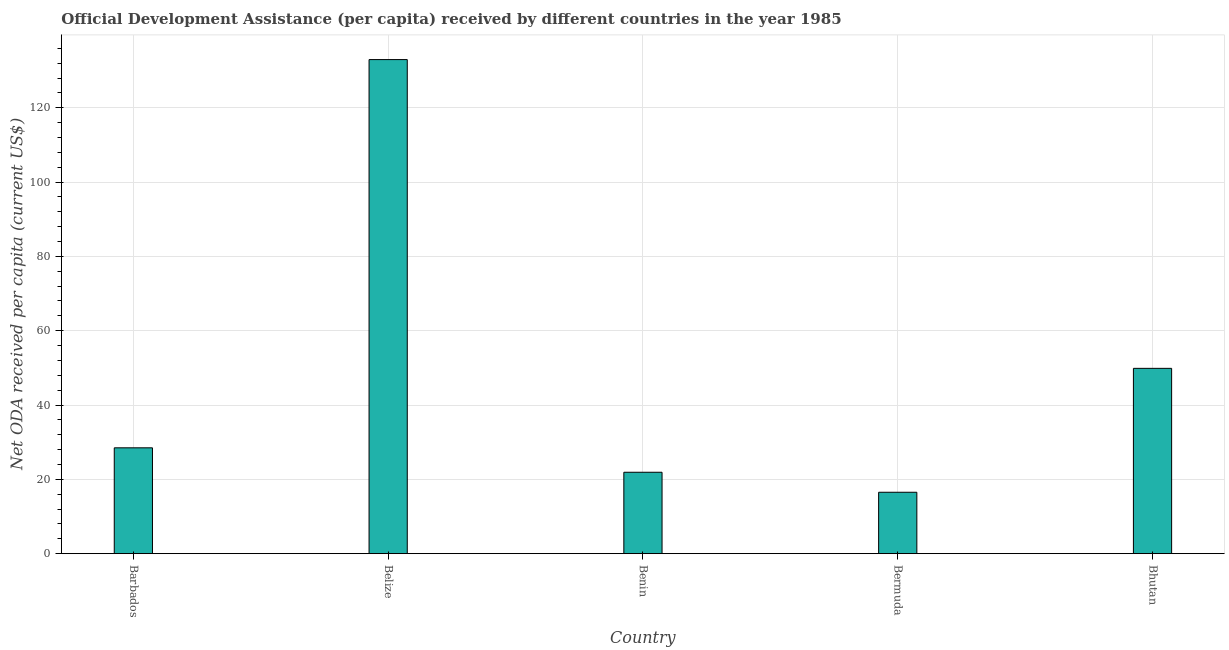What is the title of the graph?
Your response must be concise. Official Development Assistance (per capita) received by different countries in the year 1985. What is the label or title of the Y-axis?
Provide a succinct answer. Net ODA received per capita (current US$). What is the net oda received per capita in Benin?
Ensure brevity in your answer.  21.9. Across all countries, what is the maximum net oda received per capita?
Your response must be concise. 132.98. Across all countries, what is the minimum net oda received per capita?
Offer a terse response. 16.52. In which country was the net oda received per capita maximum?
Offer a terse response. Belize. In which country was the net oda received per capita minimum?
Keep it short and to the point. Bermuda. What is the sum of the net oda received per capita?
Provide a short and direct response. 249.76. What is the difference between the net oda received per capita in Barbados and Belize?
Your answer should be compact. -104.49. What is the average net oda received per capita per country?
Your answer should be very brief. 49.95. What is the median net oda received per capita?
Your response must be concise. 28.48. What is the ratio of the net oda received per capita in Belize to that in Bermuda?
Provide a short and direct response. 8.05. Is the net oda received per capita in Benin less than that in Bhutan?
Your answer should be compact. Yes. What is the difference between the highest and the second highest net oda received per capita?
Your answer should be compact. 83.11. What is the difference between the highest and the lowest net oda received per capita?
Make the answer very short. 116.46. In how many countries, is the net oda received per capita greater than the average net oda received per capita taken over all countries?
Offer a very short reply. 1. Are all the bars in the graph horizontal?
Your response must be concise. No. Are the values on the major ticks of Y-axis written in scientific E-notation?
Your answer should be compact. No. What is the Net ODA received per capita (current US$) in Barbados?
Make the answer very short. 28.48. What is the Net ODA received per capita (current US$) in Belize?
Give a very brief answer. 132.98. What is the Net ODA received per capita (current US$) of Benin?
Your answer should be compact. 21.9. What is the Net ODA received per capita (current US$) of Bermuda?
Your response must be concise. 16.52. What is the Net ODA received per capita (current US$) in Bhutan?
Offer a terse response. 49.87. What is the difference between the Net ODA received per capita (current US$) in Barbados and Belize?
Your response must be concise. -104.49. What is the difference between the Net ODA received per capita (current US$) in Barbados and Benin?
Keep it short and to the point. 6.58. What is the difference between the Net ODA received per capita (current US$) in Barbados and Bermuda?
Your response must be concise. 11.96. What is the difference between the Net ODA received per capita (current US$) in Barbados and Bhutan?
Your answer should be compact. -21.39. What is the difference between the Net ODA received per capita (current US$) in Belize and Benin?
Give a very brief answer. 111.07. What is the difference between the Net ODA received per capita (current US$) in Belize and Bermuda?
Offer a terse response. 116.46. What is the difference between the Net ODA received per capita (current US$) in Belize and Bhutan?
Your answer should be very brief. 83.11. What is the difference between the Net ODA received per capita (current US$) in Benin and Bermuda?
Make the answer very short. 5.38. What is the difference between the Net ODA received per capita (current US$) in Benin and Bhutan?
Ensure brevity in your answer.  -27.97. What is the difference between the Net ODA received per capita (current US$) in Bermuda and Bhutan?
Offer a terse response. -33.35. What is the ratio of the Net ODA received per capita (current US$) in Barbados to that in Belize?
Your response must be concise. 0.21. What is the ratio of the Net ODA received per capita (current US$) in Barbados to that in Benin?
Make the answer very short. 1.3. What is the ratio of the Net ODA received per capita (current US$) in Barbados to that in Bermuda?
Give a very brief answer. 1.72. What is the ratio of the Net ODA received per capita (current US$) in Barbados to that in Bhutan?
Your answer should be very brief. 0.57. What is the ratio of the Net ODA received per capita (current US$) in Belize to that in Benin?
Offer a very short reply. 6.07. What is the ratio of the Net ODA received per capita (current US$) in Belize to that in Bermuda?
Offer a very short reply. 8.05. What is the ratio of the Net ODA received per capita (current US$) in Belize to that in Bhutan?
Offer a very short reply. 2.67. What is the ratio of the Net ODA received per capita (current US$) in Benin to that in Bermuda?
Your response must be concise. 1.33. What is the ratio of the Net ODA received per capita (current US$) in Benin to that in Bhutan?
Your answer should be very brief. 0.44. What is the ratio of the Net ODA received per capita (current US$) in Bermuda to that in Bhutan?
Give a very brief answer. 0.33. 